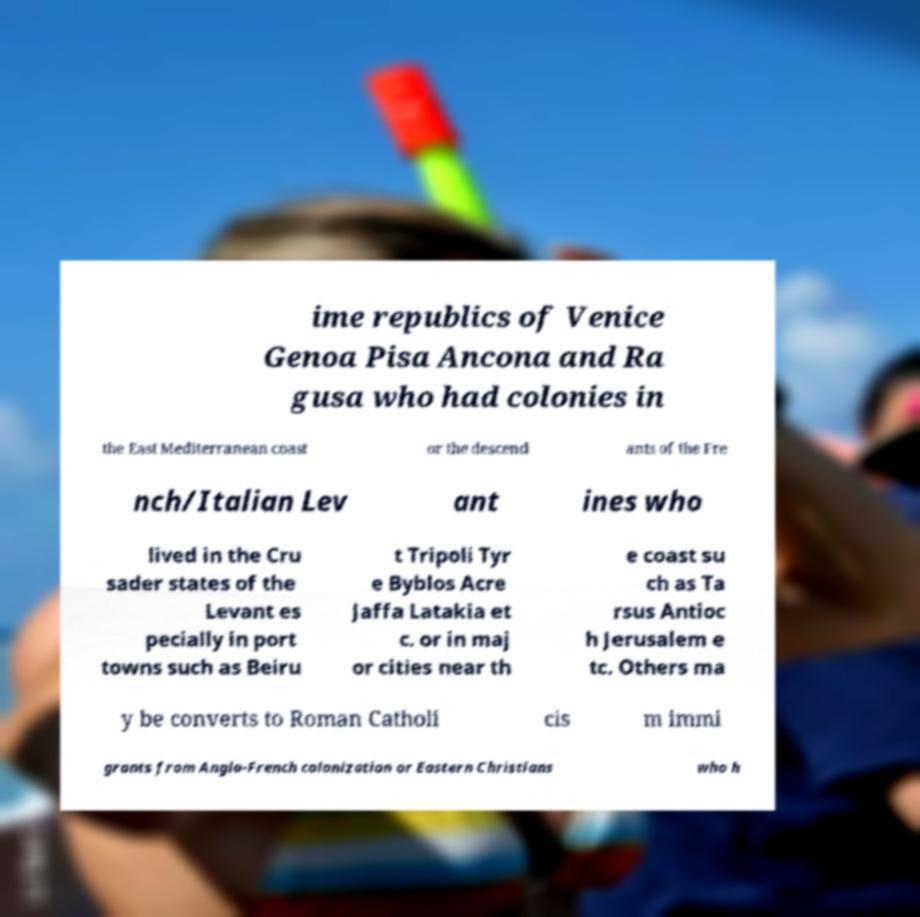Can you read and provide the text displayed in the image?This photo seems to have some interesting text. Can you extract and type it out for me? ime republics of Venice Genoa Pisa Ancona and Ra gusa who had colonies in the East Mediterranean coast or the descend ants of the Fre nch/Italian Lev ant ines who lived in the Cru sader states of the Levant es pecially in port towns such as Beiru t Tripoli Tyr e Byblos Acre Jaffa Latakia et c. or in maj or cities near th e coast su ch as Ta rsus Antioc h Jerusalem e tc. Others ma y be converts to Roman Catholi cis m immi grants from Anglo-French colonization or Eastern Christians who h 